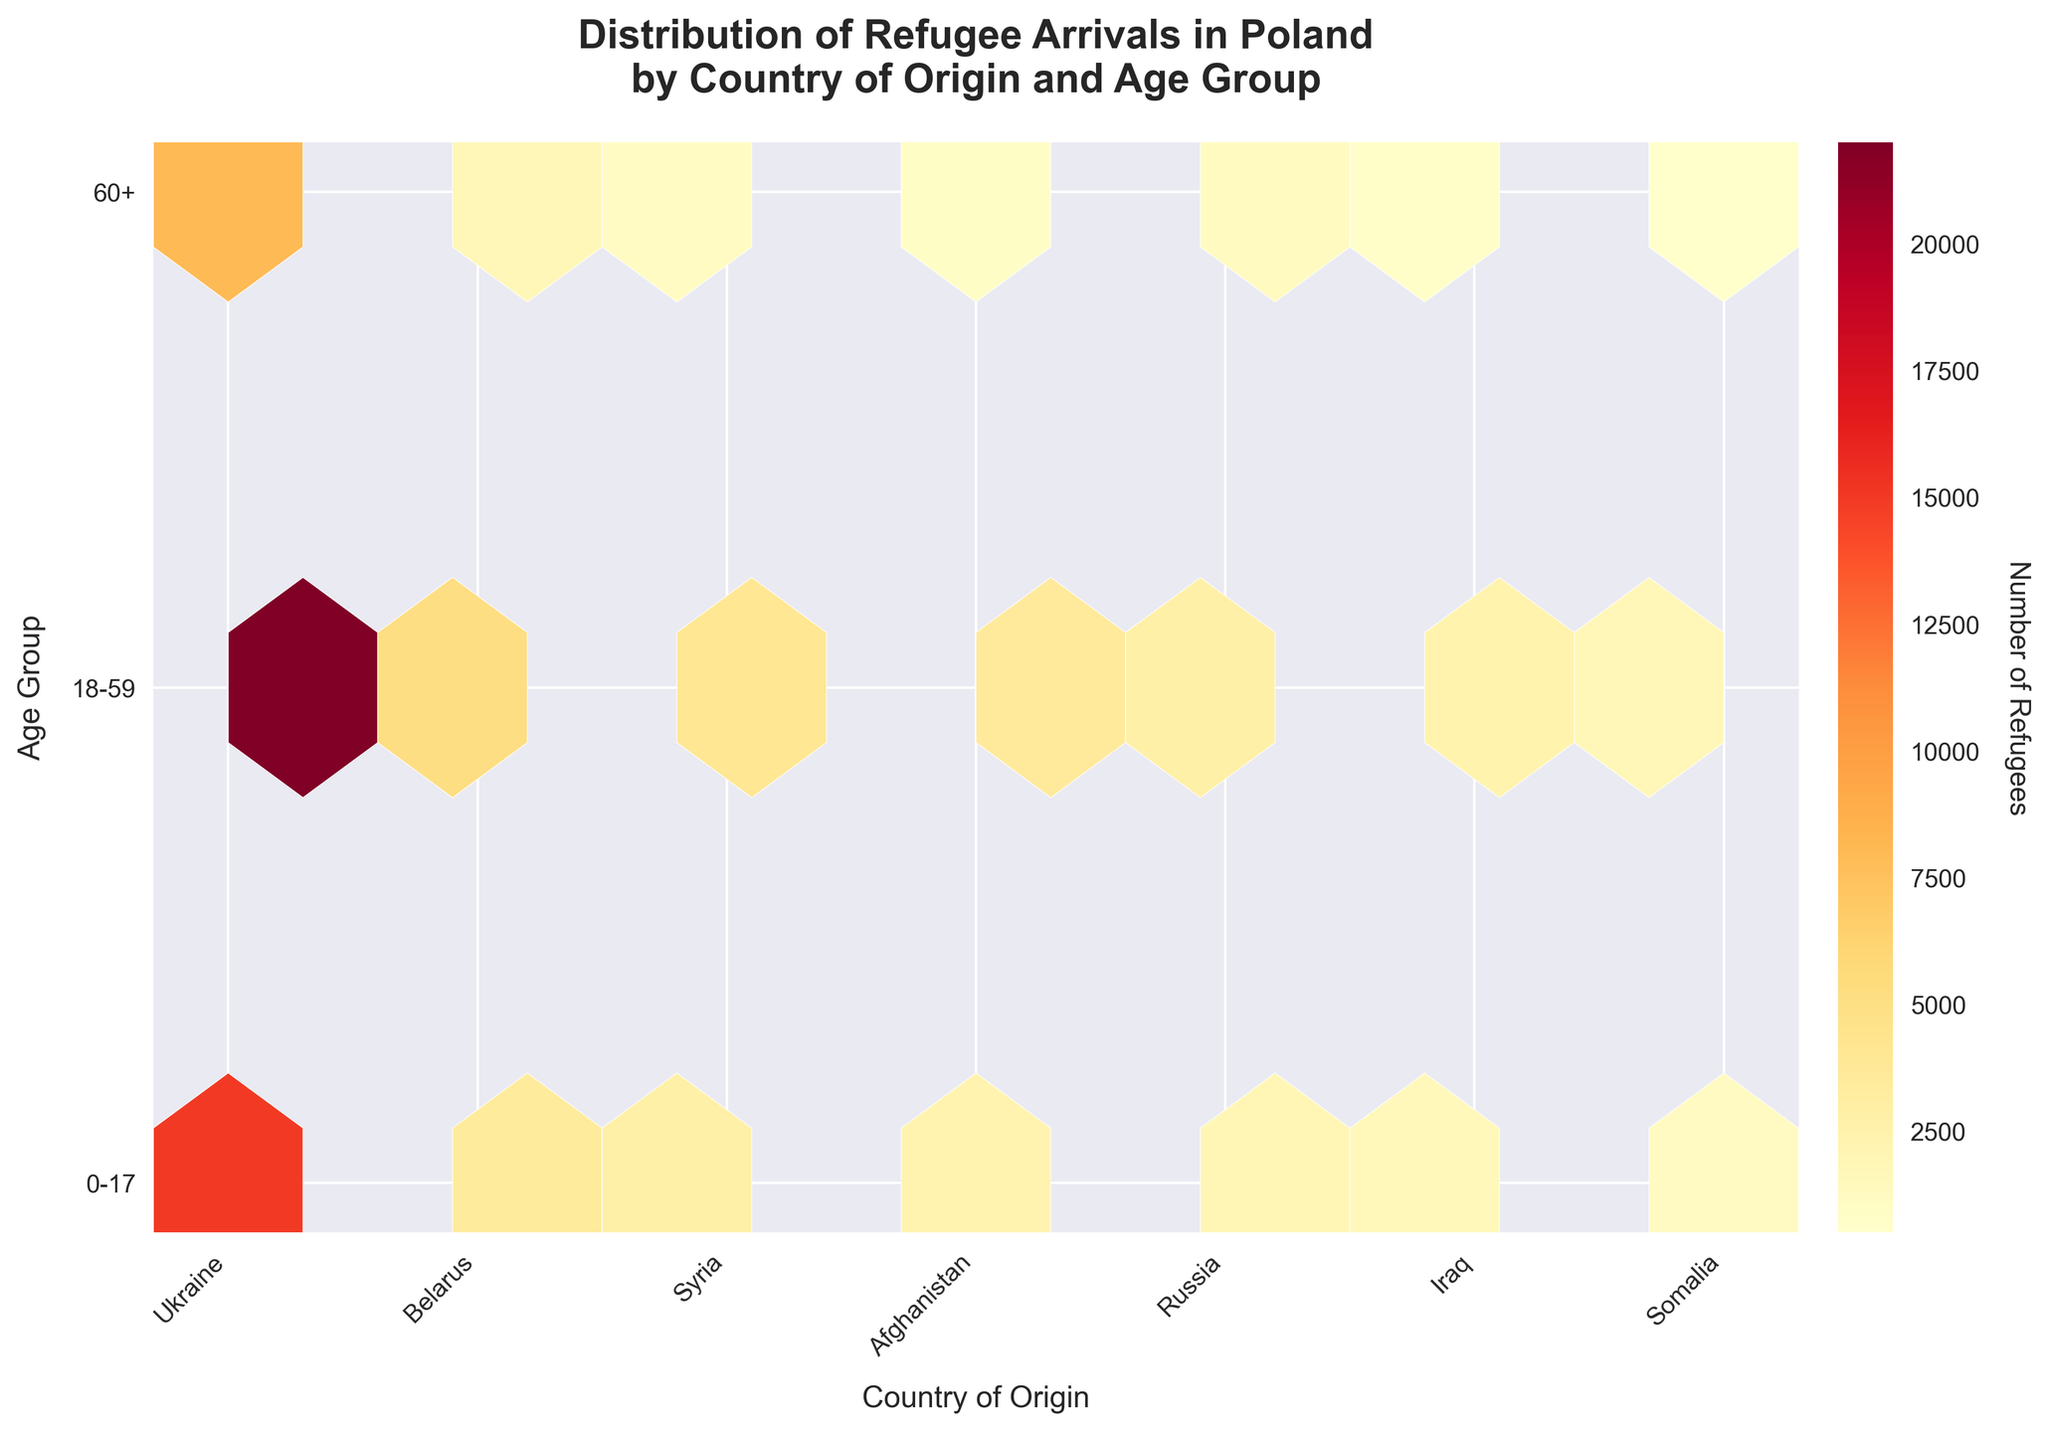What is the title of the figure? The title is located at the top of the figure, usually in bold text. It states the main subject of the plot.
Answer: Distribution of Refugee Arrivals in Poland by Country of Origin and Age Group Which country has the highest number of refugee arrivals in the 0-17 age group? Look for the brightest hexagon in the 0-17 age group row. The country corresponding to this hexagon has the highest number of refugees in that age group.
Answer: Ukraine How many countries are shown on the x-axis? Count the number of distinct tick labels on the x-axis, which represent different countries.
Answer: 6 What is the color range used in the hexbin plot? The color range is depicted by the color map used in the color bar on the figure.
Answer: Shades of yellow to red Comparing Ukraine and Belarus, which country has more refugee arrivals in the 18-59 age group? Identify the hexagons corresponding to Ukraine and Belarus in the 18-59 age group row. The brighter hexagon indicates a higher number of refugees.
Answer: Ukraine What age group has the lowest number of refugees from Somalia? Identify the row corresponding to Somalia and find the darkest hexagon, which indicates the lowest count.
Answer: 60+ What is the grid size used in the hexbin plot? The grid size is specified in the code and determines the number of hexagons along the x and y axes.
Answer: 10 (x-axis) and 3 (y-axis) Which country has the least number of refugee arrivals in the 60+ age group based on hexagon color intensity? Find the darkest hexagon in the 60+ age group row. The country corresponding to this hexagon has the least number of refugees in that age group.
Answer: Somalia Comparing all age groups, which country has the highest total number of refugee arrivals? Sum the number of hexagons for each age group for each country and compare the totals. The country with the brightest overall hexagons has the highest total.
Answer: Ukraine Which age group has the most refugee arrivals from Syria? Look at the hexagons in the rows corresponding to Syria for all age groups. The brightest hexagon indicates the age group with the most arrivals.
Answer: 18-59 